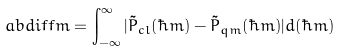Convert formula to latex. <formula><loc_0><loc_0><loc_500><loc_500>\ a b d i f f m = \int _ { - \infty } ^ { \infty } | \tilde { P } _ { c l } ( \hbar { m } ) - \tilde { P } _ { q m } ( \hbar { m } ) | d ( \hbar { m } )</formula> 